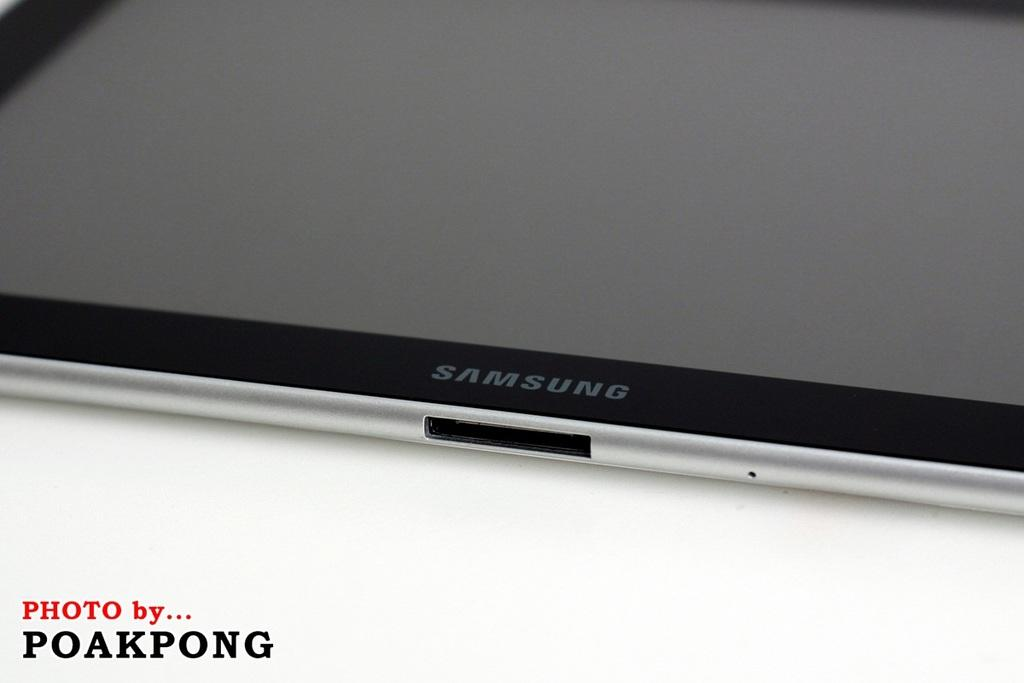<image>
Offer a succinct explanation of the picture presented. A samsung device with the photo by poakpong 